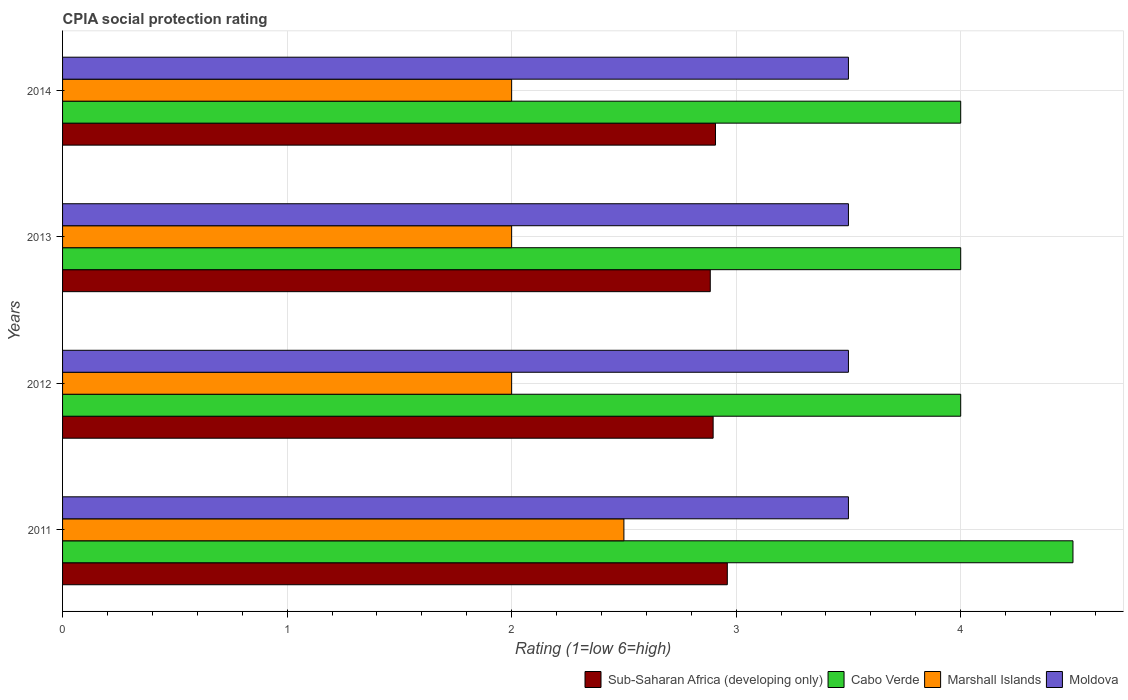Are the number of bars on each tick of the Y-axis equal?
Provide a short and direct response. Yes. What is the CPIA rating in Sub-Saharan Africa (developing only) in 2014?
Keep it short and to the point. 2.91. Across all years, what is the maximum CPIA rating in Moldova?
Your answer should be compact. 3.5. Across all years, what is the minimum CPIA rating in Moldova?
Give a very brief answer. 3.5. In which year was the CPIA rating in Cabo Verde maximum?
Your response must be concise. 2011. In which year was the CPIA rating in Marshall Islands minimum?
Offer a very short reply. 2012. What is the total CPIA rating in Marshall Islands in the graph?
Ensure brevity in your answer.  8.5. What is the difference between the CPIA rating in Cabo Verde in 2012 and that in 2014?
Offer a very short reply. 0. What is the average CPIA rating in Marshall Islands per year?
Ensure brevity in your answer.  2.12. In how many years, is the CPIA rating in Marshall Islands greater than 2 ?
Keep it short and to the point. 1. What is the ratio of the CPIA rating in Sub-Saharan Africa (developing only) in 2011 to that in 2012?
Keep it short and to the point. 1.02. Is the CPIA rating in Cabo Verde in 2011 less than that in 2014?
Offer a very short reply. No. What is the difference between the highest and the lowest CPIA rating in Marshall Islands?
Provide a succinct answer. 0.5. Is the sum of the CPIA rating in Moldova in 2012 and 2013 greater than the maximum CPIA rating in Cabo Verde across all years?
Your answer should be compact. Yes. What does the 4th bar from the top in 2012 represents?
Your answer should be very brief. Sub-Saharan Africa (developing only). What does the 2nd bar from the bottom in 2014 represents?
Your answer should be very brief. Cabo Verde. Is it the case that in every year, the sum of the CPIA rating in Cabo Verde and CPIA rating in Sub-Saharan Africa (developing only) is greater than the CPIA rating in Marshall Islands?
Offer a very short reply. Yes. How many bars are there?
Your response must be concise. 16. Are all the bars in the graph horizontal?
Offer a terse response. Yes. What is the difference between two consecutive major ticks on the X-axis?
Offer a terse response. 1. Does the graph contain any zero values?
Give a very brief answer. No. Where does the legend appear in the graph?
Give a very brief answer. Bottom right. How many legend labels are there?
Offer a very short reply. 4. What is the title of the graph?
Offer a very short reply. CPIA social protection rating. Does "Moldova" appear as one of the legend labels in the graph?
Provide a succinct answer. Yes. What is the label or title of the X-axis?
Ensure brevity in your answer.  Rating (1=low 6=high). What is the Rating (1=low 6=high) of Sub-Saharan Africa (developing only) in 2011?
Your answer should be very brief. 2.96. What is the Rating (1=low 6=high) in Cabo Verde in 2011?
Offer a very short reply. 4.5. What is the Rating (1=low 6=high) of Marshall Islands in 2011?
Make the answer very short. 2.5. What is the Rating (1=low 6=high) of Moldova in 2011?
Give a very brief answer. 3.5. What is the Rating (1=low 6=high) of Sub-Saharan Africa (developing only) in 2012?
Ensure brevity in your answer.  2.9. What is the Rating (1=low 6=high) in Sub-Saharan Africa (developing only) in 2013?
Keep it short and to the point. 2.88. What is the Rating (1=low 6=high) of Sub-Saharan Africa (developing only) in 2014?
Offer a very short reply. 2.91. What is the Rating (1=low 6=high) of Cabo Verde in 2014?
Ensure brevity in your answer.  4. What is the Rating (1=low 6=high) of Marshall Islands in 2014?
Offer a terse response. 2. What is the Rating (1=low 6=high) in Moldova in 2014?
Give a very brief answer. 3.5. Across all years, what is the maximum Rating (1=low 6=high) in Sub-Saharan Africa (developing only)?
Provide a succinct answer. 2.96. Across all years, what is the maximum Rating (1=low 6=high) of Marshall Islands?
Make the answer very short. 2.5. Across all years, what is the minimum Rating (1=low 6=high) of Sub-Saharan Africa (developing only)?
Keep it short and to the point. 2.88. What is the total Rating (1=low 6=high) in Sub-Saharan Africa (developing only) in the graph?
Provide a succinct answer. 11.65. What is the total Rating (1=low 6=high) in Cabo Verde in the graph?
Ensure brevity in your answer.  16.5. What is the difference between the Rating (1=low 6=high) of Sub-Saharan Africa (developing only) in 2011 and that in 2012?
Your answer should be very brief. 0.06. What is the difference between the Rating (1=low 6=high) of Cabo Verde in 2011 and that in 2012?
Offer a terse response. 0.5. What is the difference between the Rating (1=low 6=high) of Marshall Islands in 2011 and that in 2012?
Offer a very short reply. 0.5. What is the difference between the Rating (1=low 6=high) in Sub-Saharan Africa (developing only) in 2011 and that in 2013?
Provide a short and direct response. 0.08. What is the difference between the Rating (1=low 6=high) of Cabo Verde in 2011 and that in 2013?
Provide a short and direct response. 0.5. What is the difference between the Rating (1=low 6=high) in Marshall Islands in 2011 and that in 2013?
Give a very brief answer. 0.5. What is the difference between the Rating (1=low 6=high) in Sub-Saharan Africa (developing only) in 2011 and that in 2014?
Your answer should be very brief. 0.05. What is the difference between the Rating (1=low 6=high) of Marshall Islands in 2011 and that in 2014?
Ensure brevity in your answer.  0.5. What is the difference between the Rating (1=low 6=high) in Sub-Saharan Africa (developing only) in 2012 and that in 2013?
Offer a very short reply. 0.01. What is the difference between the Rating (1=low 6=high) in Cabo Verde in 2012 and that in 2013?
Your response must be concise. 0. What is the difference between the Rating (1=low 6=high) in Marshall Islands in 2012 and that in 2013?
Your response must be concise. 0. What is the difference between the Rating (1=low 6=high) of Moldova in 2012 and that in 2013?
Provide a short and direct response. 0. What is the difference between the Rating (1=low 6=high) of Sub-Saharan Africa (developing only) in 2012 and that in 2014?
Ensure brevity in your answer.  -0.01. What is the difference between the Rating (1=low 6=high) of Marshall Islands in 2012 and that in 2014?
Provide a succinct answer. 0. What is the difference between the Rating (1=low 6=high) of Sub-Saharan Africa (developing only) in 2013 and that in 2014?
Your response must be concise. -0.02. What is the difference between the Rating (1=low 6=high) of Moldova in 2013 and that in 2014?
Keep it short and to the point. 0. What is the difference between the Rating (1=low 6=high) in Sub-Saharan Africa (developing only) in 2011 and the Rating (1=low 6=high) in Cabo Verde in 2012?
Your response must be concise. -1.04. What is the difference between the Rating (1=low 6=high) in Sub-Saharan Africa (developing only) in 2011 and the Rating (1=low 6=high) in Marshall Islands in 2012?
Give a very brief answer. 0.96. What is the difference between the Rating (1=low 6=high) in Sub-Saharan Africa (developing only) in 2011 and the Rating (1=low 6=high) in Moldova in 2012?
Offer a very short reply. -0.54. What is the difference between the Rating (1=low 6=high) of Cabo Verde in 2011 and the Rating (1=low 6=high) of Moldova in 2012?
Provide a short and direct response. 1. What is the difference between the Rating (1=low 6=high) of Sub-Saharan Africa (developing only) in 2011 and the Rating (1=low 6=high) of Cabo Verde in 2013?
Provide a short and direct response. -1.04. What is the difference between the Rating (1=low 6=high) of Sub-Saharan Africa (developing only) in 2011 and the Rating (1=low 6=high) of Marshall Islands in 2013?
Make the answer very short. 0.96. What is the difference between the Rating (1=low 6=high) in Sub-Saharan Africa (developing only) in 2011 and the Rating (1=low 6=high) in Moldova in 2013?
Provide a succinct answer. -0.54. What is the difference between the Rating (1=low 6=high) in Cabo Verde in 2011 and the Rating (1=low 6=high) in Moldova in 2013?
Give a very brief answer. 1. What is the difference between the Rating (1=low 6=high) in Sub-Saharan Africa (developing only) in 2011 and the Rating (1=low 6=high) in Cabo Verde in 2014?
Your answer should be very brief. -1.04. What is the difference between the Rating (1=low 6=high) of Sub-Saharan Africa (developing only) in 2011 and the Rating (1=low 6=high) of Marshall Islands in 2014?
Provide a short and direct response. 0.96. What is the difference between the Rating (1=low 6=high) of Sub-Saharan Africa (developing only) in 2011 and the Rating (1=low 6=high) of Moldova in 2014?
Offer a terse response. -0.54. What is the difference between the Rating (1=low 6=high) of Cabo Verde in 2011 and the Rating (1=low 6=high) of Moldova in 2014?
Your response must be concise. 1. What is the difference between the Rating (1=low 6=high) of Sub-Saharan Africa (developing only) in 2012 and the Rating (1=low 6=high) of Cabo Verde in 2013?
Give a very brief answer. -1.1. What is the difference between the Rating (1=low 6=high) in Sub-Saharan Africa (developing only) in 2012 and the Rating (1=low 6=high) in Marshall Islands in 2013?
Keep it short and to the point. 0.9. What is the difference between the Rating (1=low 6=high) of Sub-Saharan Africa (developing only) in 2012 and the Rating (1=low 6=high) of Moldova in 2013?
Make the answer very short. -0.6. What is the difference between the Rating (1=low 6=high) of Cabo Verde in 2012 and the Rating (1=low 6=high) of Marshall Islands in 2013?
Offer a very short reply. 2. What is the difference between the Rating (1=low 6=high) in Cabo Verde in 2012 and the Rating (1=low 6=high) in Moldova in 2013?
Offer a very short reply. 0.5. What is the difference between the Rating (1=low 6=high) of Marshall Islands in 2012 and the Rating (1=low 6=high) of Moldova in 2013?
Your response must be concise. -1.5. What is the difference between the Rating (1=low 6=high) in Sub-Saharan Africa (developing only) in 2012 and the Rating (1=low 6=high) in Cabo Verde in 2014?
Give a very brief answer. -1.1. What is the difference between the Rating (1=low 6=high) in Sub-Saharan Africa (developing only) in 2012 and the Rating (1=low 6=high) in Marshall Islands in 2014?
Ensure brevity in your answer.  0.9. What is the difference between the Rating (1=low 6=high) in Sub-Saharan Africa (developing only) in 2012 and the Rating (1=low 6=high) in Moldova in 2014?
Make the answer very short. -0.6. What is the difference between the Rating (1=low 6=high) in Cabo Verde in 2012 and the Rating (1=low 6=high) in Moldova in 2014?
Provide a short and direct response. 0.5. What is the difference between the Rating (1=low 6=high) in Marshall Islands in 2012 and the Rating (1=low 6=high) in Moldova in 2014?
Keep it short and to the point. -1.5. What is the difference between the Rating (1=low 6=high) of Sub-Saharan Africa (developing only) in 2013 and the Rating (1=low 6=high) of Cabo Verde in 2014?
Offer a very short reply. -1.12. What is the difference between the Rating (1=low 6=high) in Sub-Saharan Africa (developing only) in 2013 and the Rating (1=low 6=high) in Marshall Islands in 2014?
Make the answer very short. 0.88. What is the difference between the Rating (1=low 6=high) in Sub-Saharan Africa (developing only) in 2013 and the Rating (1=low 6=high) in Moldova in 2014?
Ensure brevity in your answer.  -0.62. What is the difference between the Rating (1=low 6=high) of Cabo Verde in 2013 and the Rating (1=low 6=high) of Marshall Islands in 2014?
Give a very brief answer. 2. What is the difference between the Rating (1=low 6=high) of Marshall Islands in 2013 and the Rating (1=low 6=high) of Moldova in 2014?
Make the answer very short. -1.5. What is the average Rating (1=low 6=high) of Sub-Saharan Africa (developing only) per year?
Provide a short and direct response. 2.91. What is the average Rating (1=low 6=high) in Cabo Verde per year?
Your answer should be very brief. 4.12. What is the average Rating (1=low 6=high) of Marshall Islands per year?
Give a very brief answer. 2.12. What is the average Rating (1=low 6=high) of Moldova per year?
Your answer should be very brief. 3.5. In the year 2011, what is the difference between the Rating (1=low 6=high) in Sub-Saharan Africa (developing only) and Rating (1=low 6=high) in Cabo Verde?
Provide a short and direct response. -1.54. In the year 2011, what is the difference between the Rating (1=low 6=high) of Sub-Saharan Africa (developing only) and Rating (1=low 6=high) of Marshall Islands?
Provide a succinct answer. 0.46. In the year 2011, what is the difference between the Rating (1=low 6=high) of Sub-Saharan Africa (developing only) and Rating (1=low 6=high) of Moldova?
Ensure brevity in your answer.  -0.54. In the year 2012, what is the difference between the Rating (1=low 6=high) of Sub-Saharan Africa (developing only) and Rating (1=low 6=high) of Cabo Verde?
Make the answer very short. -1.1. In the year 2012, what is the difference between the Rating (1=low 6=high) in Sub-Saharan Africa (developing only) and Rating (1=low 6=high) in Marshall Islands?
Make the answer very short. 0.9. In the year 2012, what is the difference between the Rating (1=low 6=high) of Sub-Saharan Africa (developing only) and Rating (1=low 6=high) of Moldova?
Your answer should be very brief. -0.6. In the year 2012, what is the difference between the Rating (1=low 6=high) of Marshall Islands and Rating (1=low 6=high) of Moldova?
Provide a short and direct response. -1.5. In the year 2013, what is the difference between the Rating (1=low 6=high) in Sub-Saharan Africa (developing only) and Rating (1=low 6=high) in Cabo Verde?
Give a very brief answer. -1.12. In the year 2013, what is the difference between the Rating (1=low 6=high) of Sub-Saharan Africa (developing only) and Rating (1=low 6=high) of Marshall Islands?
Give a very brief answer. 0.88. In the year 2013, what is the difference between the Rating (1=low 6=high) in Sub-Saharan Africa (developing only) and Rating (1=low 6=high) in Moldova?
Make the answer very short. -0.62. In the year 2013, what is the difference between the Rating (1=low 6=high) of Marshall Islands and Rating (1=low 6=high) of Moldova?
Offer a terse response. -1.5. In the year 2014, what is the difference between the Rating (1=low 6=high) in Sub-Saharan Africa (developing only) and Rating (1=low 6=high) in Cabo Verde?
Offer a very short reply. -1.09. In the year 2014, what is the difference between the Rating (1=low 6=high) in Sub-Saharan Africa (developing only) and Rating (1=low 6=high) in Marshall Islands?
Make the answer very short. 0.91. In the year 2014, what is the difference between the Rating (1=low 6=high) in Sub-Saharan Africa (developing only) and Rating (1=low 6=high) in Moldova?
Make the answer very short. -0.59. In the year 2014, what is the difference between the Rating (1=low 6=high) in Marshall Islands and Rating (1=low 6=high) in Moldova?
Provide a short and direct response. -1.5. What is the ratio of the Rating (1=low 6=high) of Sub-Saharan Africa (developing only) in 2011 to that in 2012?
Your response must be concise. 1.02. What is the ratio of the Rating (1=low 6=high) in Cabo Verde in 2011 to that in 2012?
Provide a succinct answer. 1.12. What is the ratio of the Rating (1=low 6=high) of Marshall Islands in 2011 to that in 2012?
Keep it short and to the point. 1.25. What is the ratio of the Rating (1=low 6=high) in Sub-Saharan Africa (developing only) in 2011 to that in 2013?
Your response must be concise. 1.03. What is the ratio of the Rating (1=low 6=high) of Moldova in 2011 to that in 2013?
Your response must be concise. 1. What is the ratio of the Rating (1=low 6=high) in Sub-Saharan Africa (developing only) in 2011 to that in 2014?
Offer a very short reply. 1.02. What is the ratio of the Rating (1=low 6=high) in Marshall Islands in 2011 to that in 2014?
Offer a terse response. 1.25. What is the ratio of the Rating (1=low 6=high) in Moldova in 2011 to that in 2014?
Provide a short and direct response. 1. What is the ratio of the Rating (1=low 6=high) in Moldova in 2012 to that in 2013?
Provide a succinct answer. 1. What is the ratio of the Rating (1=low 6=high) in Cabo Verde in 2012 to that in 2014?
Keep it short and to the point. 1. What is the ratio of the Rating (1=low 6=high) of Marshall Islands in 2013 to that in 2014?
Offer a terse response. 1. What is the difference between the highest and the second highest Rating (1=low 6=high) of Sub-Saharan Africa (developing only)?
Your answer should be compact. 0.05. What is the difference between the highest and the lowest Rating (1=low 6=high) of Sub-Saharan Africa (developing only)?
Offer a terse response. 0.08. What is the difference between the highest and the lowest Rating (1=low 6=high) in Cabo Verde?
Provide a succinct answer. 0.5. What is the difference between the highest and the lowest Rating (1=low 6=high) in Marshall Islands?
Provide a succinct answer. 0.5. What is the difference between the highest and the lowest Rating (1=low 6=high) of Moldova?
Your answer should be very brief. 0. 